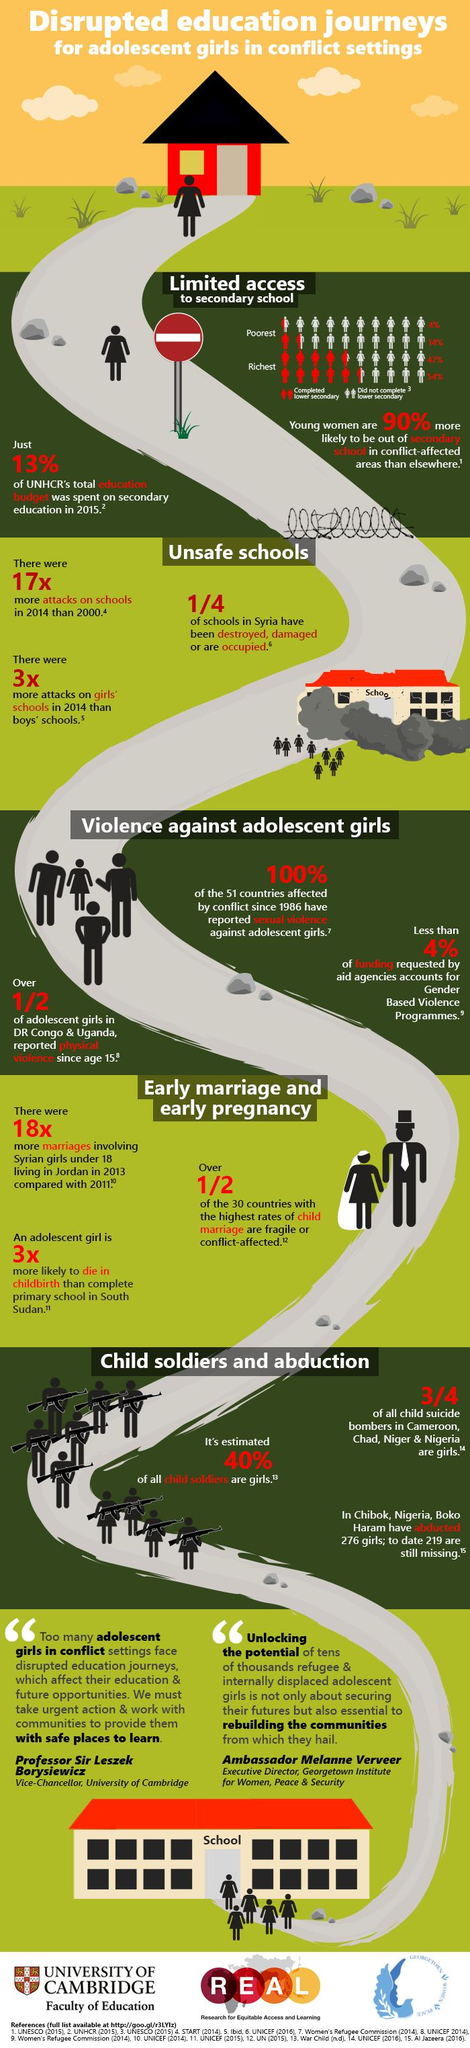Identify some key points in this picture. According to the data, 14% of boys living in poverty were able to complete lower secondary school. According to the data, only 4% of girls living in poverty were able to complete lower secondary school. In the country where the study was conducted, 54% of boys who were able to afford education were able to complete lower secondary school. 